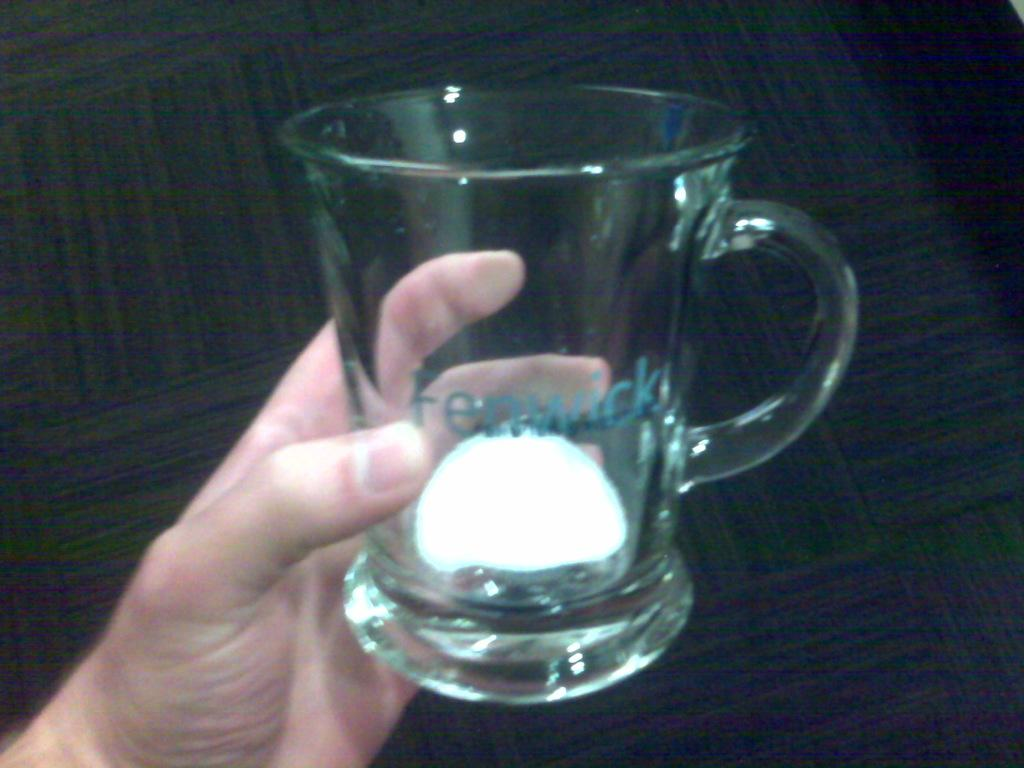Who is present in the image? There is a person in the image. What is the person holding in the image? The person is holding a glass. What color is the glass? The glass is white in color. What can be seen in the background of the image? There is a carpet in the background of the image. What color is the carpet? The carpet is black in color. What type of cream is being used by the person in the image? There is no cream visible in the image, and the person is not using any cream. 